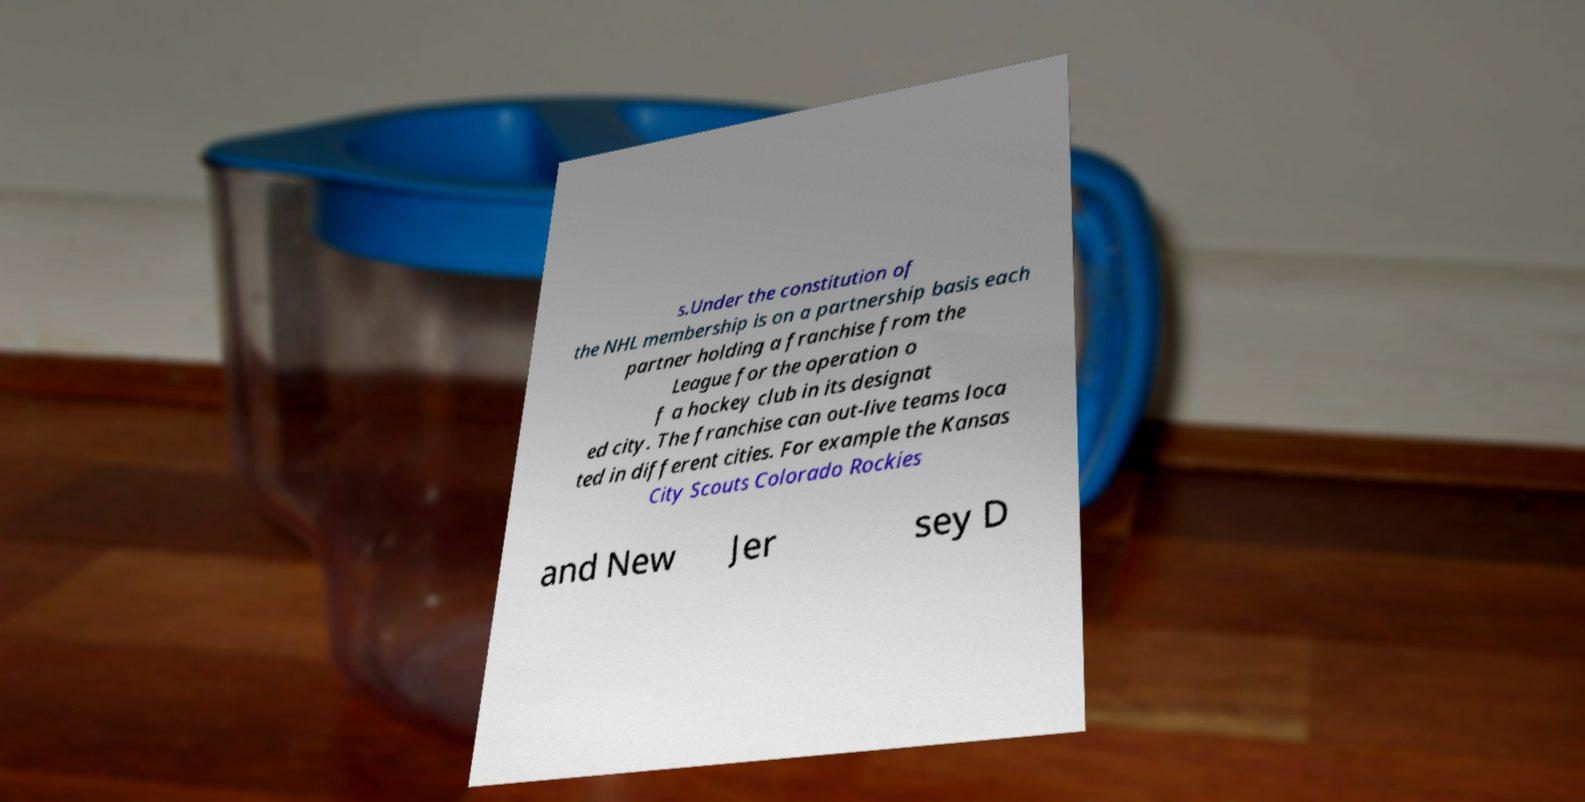I need the written content from this picture converted into text. Can you do that? s.Under the constitution of the NHL membership is on a partnership basis each partner holding a franchise from the League for the operation o f a hockey club in its designat ed city. The franchise can out-live teams loca ted in different cities. For example the Kansas City Scouts Colorado Rockies and New Jer sey D 